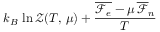Convert formula to latex. <formula><loc_0><loc_0><loc_500><loc_500>k _ { B } \, \ln \mathcal { Z } ( T , \, \mu ) + \frac { \overline { { \mathcal { F } _ { e } } } - \mu \, \overline { \mathcal { F } } _ { n } } { T }</formula> 